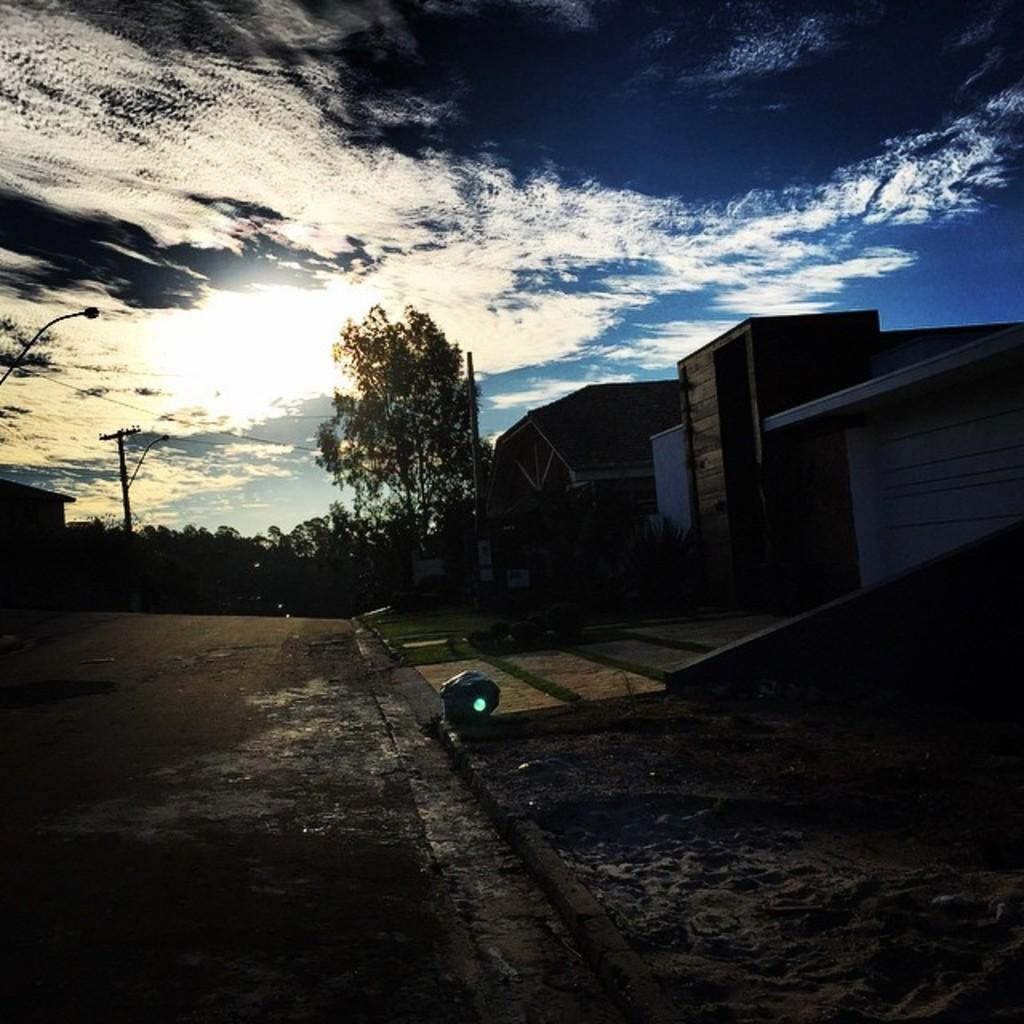What type of structures can be seen on the right side of the image? There are houses on the right side of the image. What type of vegetation is present in the image? There are trees in the image. What else can be seen in the image besides houses and trees? There are poles in the image. What is visible at the top of the image? The sky is visible at the top of the image. Can you see any apples growing on the trees in the image? There is no mention of apples in the image, so it cannot be determined if any are present. Are there any bushes visible in the image? There is no mention of bushes in the image, so it cannot be determined if any are present. 